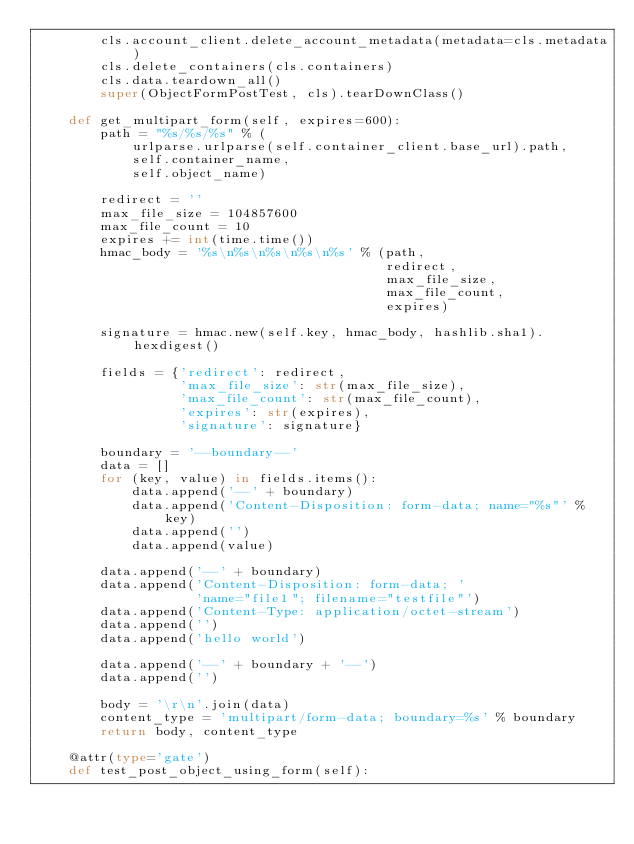<code> <loc_0><loc_0><loc_500><loc_500><_Python_>        cls.account_client.delete_account_metadata(metadata=cls.metadata)
        cls.delete_containers(cls.containers)
        cls.data.teardown_all()
        super(ObjectFormPostTest, cls).tearDownClass()

    def get_multipart_form(self, expires=600):
        path = "%s/%s/%s" % (
            urlparse.urlparse(self.container_client.base_url).path,
            self.container_name,
            self.object_name)

        redirect = ''
        max_file_size = 104857600
        max_file_count = 10
        expires += int(time.time())
        hmac_body = '%s\n%s\n%s\n%s\n%s' % (path,
                                            redirect,
                                            max_file_size,
                                            max_file_count,
                                            expires)

        signature = hmac.new(self.key, hmac_body, hashlib.sha1).hexdigest()

        fields = {'redirect': redirect,
                  'max_file_size': str(max_file_size),
                  'max_file_count': str(max_file_count),
                  'expires': str(expires),
                  'signature': signature}

        boundary = '--boundary--'
        data = []
        for (key, value) in fields.items():
            data.append('--' + boundary)
            data.append('Content-Disposition: form-data; name="%s"' % key)
            data.append('')
            data.append(value)

        data.append('--' + boundary)
        data.append('Content-Disposition: form-data; '
                    'name="file1"; filename="testfile"')
        data.append('Content-Type: application/octet-stream')
        data.append('')
        data.append('hello world')

        data.append('--' + boundary + '--')
        data.append('')

        body = '\r\n'.join(data)
        content_type = 'multipart/form-data; boundary=%s' % boundary
        return body, content_type

    @attr(type='gate')
    def test_post_object_using_form(self):</code> 